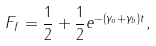<formula> <loc_0><loc_0><loc_500><loc_500>F _ { f } = \frac { 1 } { 2 } + \frac { 1 } { 2 } e ^ { - ( \gamma _ { a } + \gamma _ { b } ) t } ,</formula> 